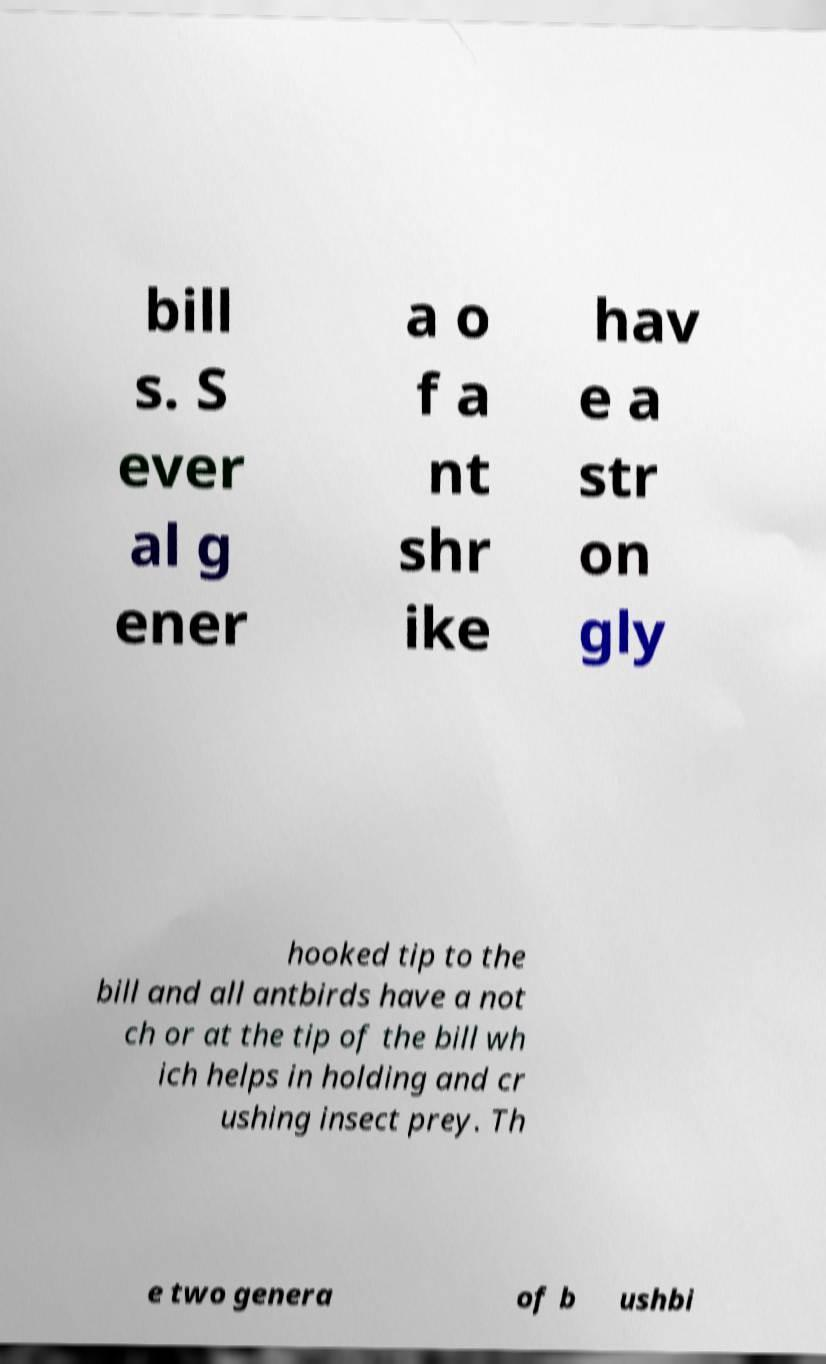What messages or text are displayed in this image? I need them in a readable, typed format. bill s. S ever al g ener a o f a nt shr ike hav e a str on gly hooked tip to the bill and all antbirds have a not ch or at the tip of the bill wh ich helps in holding and cr ushing insect prey. Th e two genera of b ushbi 